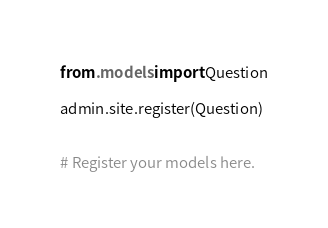<code> <loc_0><loc_0><loc_500><loc_500><_Python_>from .models import Question

admin.site.register(Question)


# Register your models here.
</code> 